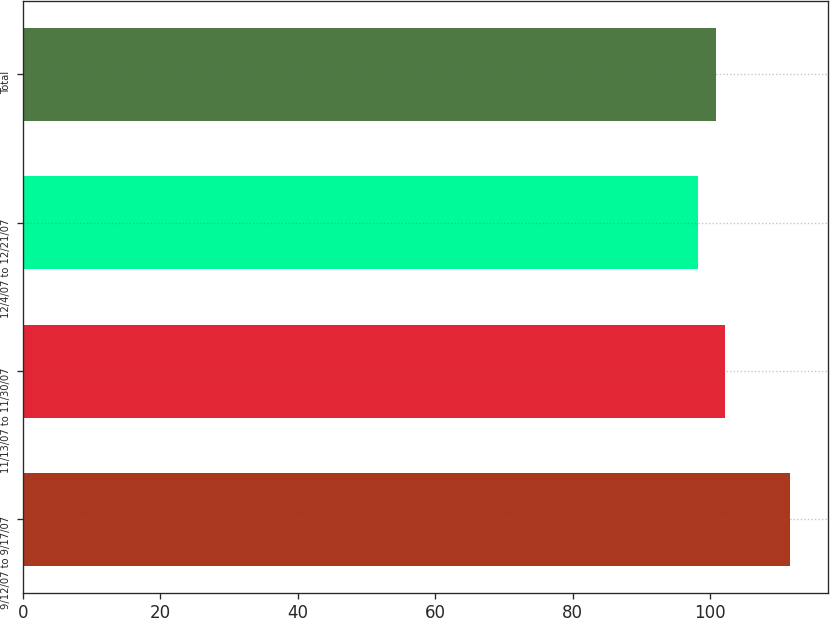Convert chart. <chart><loc_0><loc_0><loc_500><loc_500><bar_chart><fcel>9/12/07 to 9/17/07<fcel>11/13/07 to 11/30/07<fcel>12/4/07 to 12/21/07<fcel>Total<nl><fcel>111.6<fcel>102.24<fcel>98.2<fcel>100.9<nl></chart> 